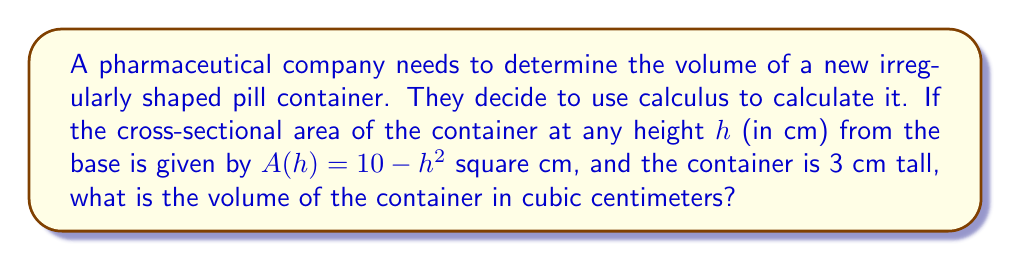Can you solve this math problem? To find the volume of an irregularly shaped container, we can use the method of integration. Here's how we can solve this problem step by step:

1) The volume of a solid with known cross-sectional area can be found by integrating the area function over the height of the solid.

2) We are given that the cross-sectional area function is:
   $A(h) = 10 - h^2$

3) The height of the container is 3 cm, so we need to integrate from 0 to 3:

   $V = \int_0^3 A(h) dh = \int_0^3 (10 - h^2) dh$

4) Let's solve this integral:

   $V = \left[10h - \frac{1}{3}h^3\right]_0^3$

5) Now we evaluate the expression at the upper and lower limits:

   $V = \left(10(3) - \frac{1}{3}(3)^3\right) - \left(10(0) - \frac{1}{3}(0)^3\right)$

6) Simplify:

   $V = (30 - 9) - 0 = 21$

Therefore, the volume of the container is 21 cubic centimeters.
Answer: 21 cm³ 